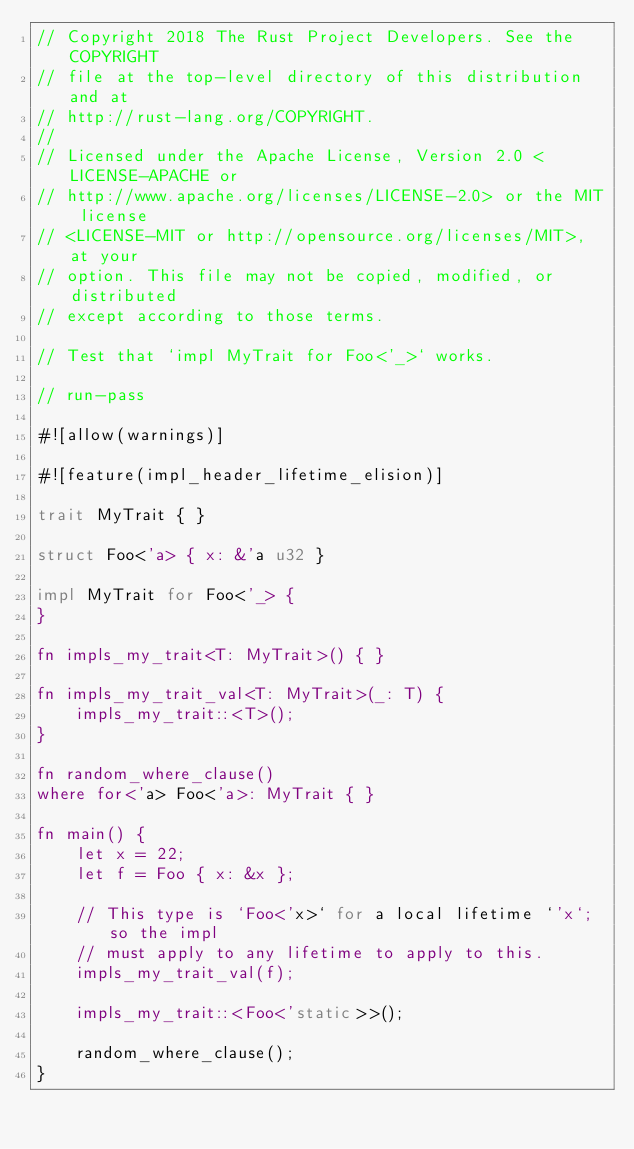Convert code to text. <code><loc_0><loc_0><loc_500><loc_500><_Rust_>// Copyright 2018 The Rust Project Developers. See the COPYRIGHT
// file at the top-level directory of this distribution and at
// http://rust-lang.org/COPYRIGHT.
//
// Licensed under the Apache License, Version 2.0 <LICENSE-APACHE or
// http://www.apache.org/licenses/LICENSE-2.0> or the MIT license
// <LICENSE-MIT or http://opensource.org/licenses/MIT>, at your
// option. This file may not be copied, modified, or distributed
// except according to those terms.

// Test that `impl MyTrait for Foo<'_>` works.

// run-pass

#![allow(warnings)]

#![feature(impl_header_lifetime_elision)]

trait MyTrait { }

struct Foo<'a> { x: &'a u32 }

impl MyTrait for Foo<'_> {
}

fn impls_my_trait<T: MyTrait>() { }

fn impls_my_trait_val<T: MyTrait>(_: T) {
    impls_my_trait::<T>();
}

fn random_where_clause()
where for<'a> Foo<'a>: MyTrait { }

fn main() {
    let x = 22;
    let f = Foo { x: &x };

    // This type is `Foo<'x>` for a local lifetime `'x`; so the impl
    // must apply to any lifetime to apply to this.
    impls_my_trait_val(f);

    impls_my_trait::<Foo<'static>>();

    random_where_clause();
}
</code> 